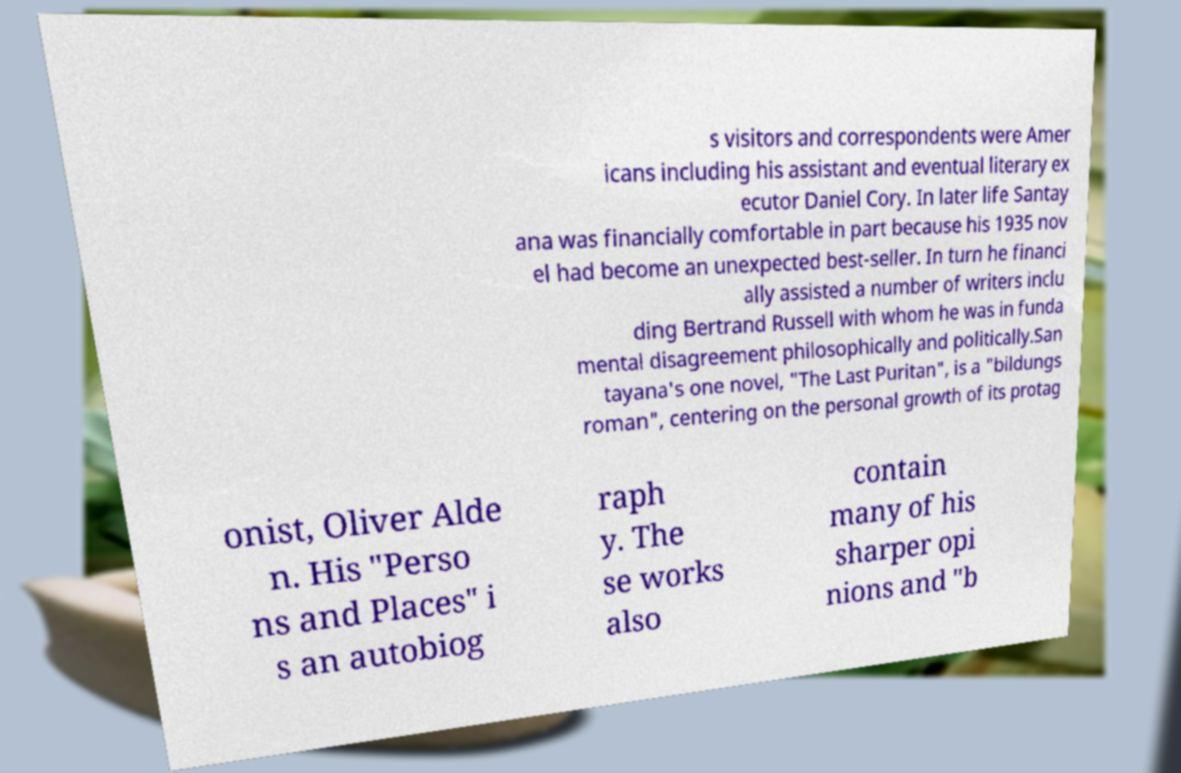What messages or text are displayed in this image? I need them in a readable, typed format. s visitors and correspondents were Amer icans including his assistant and eventual literary ex ecutor Daniel Cory. In later life Santay ana was financially comfortable in part because his 1935 nov el had become an unexpected best-seller. In turn he financi ally assisted a number of writers inclu ding Bertrand Russell with whom he was in funda mental disagreement philosophically and politically.San tayana's one novel, "The Last Puritan", is a "bildungs roman", centering on the personal growth of its protag onist, Oliver Alde n. His "Perso ns and Places" i s an autobiog raph y. The se works also contain many of his sharper opi nions and "b 